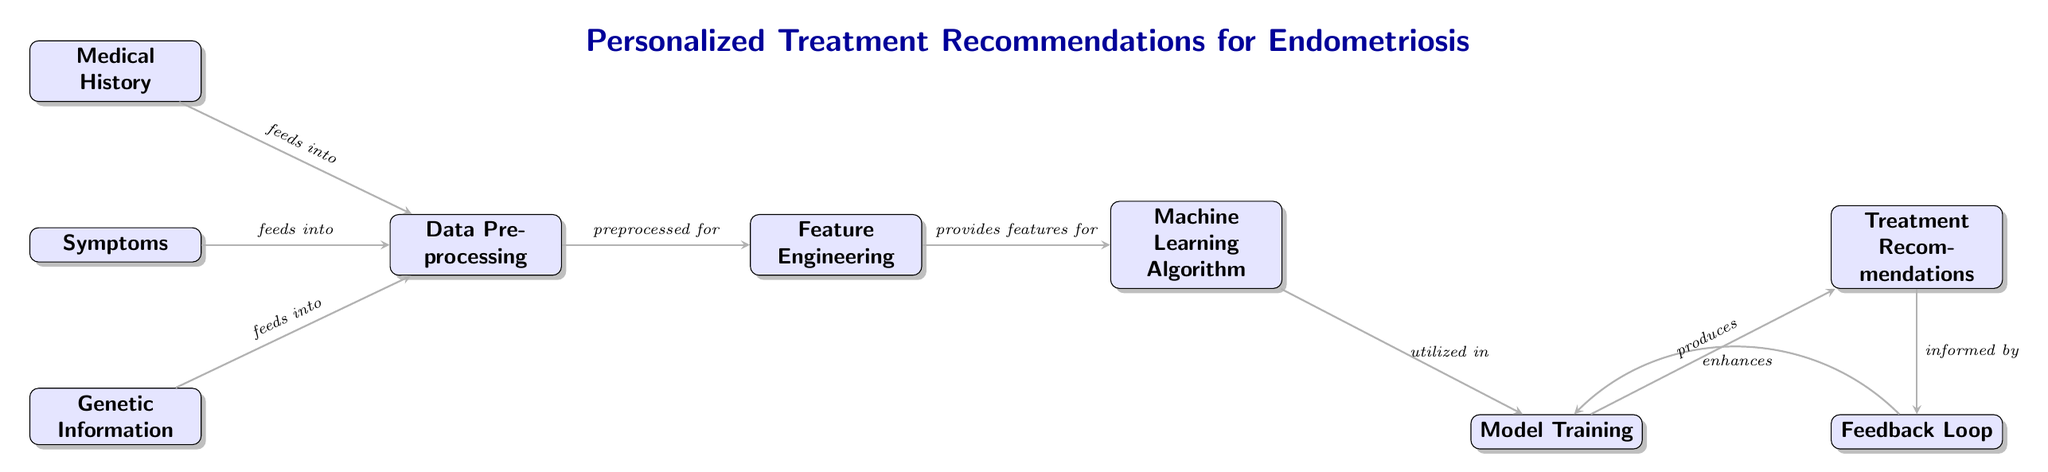What are the three types of input data to the model? The diagram shows three nodes at the beginning: "Medical History," "Symptoms," and "Genetic Information." These nodes represent the different types of input data that feed into the model.
Answer: Medical History, Symptoms, Genetic Information What process is applied after data preprocessing? The diagram illustrates an arrow leading from "Data Preprocessing" to "Feature Engineering." This indicates that "Feature Engineering" is the next step following data preprocessing.
Answer: Feature Engineering How many main nodes are in the diagram? By counting the distinct nodes present in the diagram, there are eight nodes in total: Medical History, Symptoms, Genetic Information, Data Preprocessing, Feature Engineering, Machine Learning Algorithm, Model Training, and Treatment Recommendations.
Answer: Eight What does the feedback loop do in the diagram? The feedback loop connects back to "Model Training" to enhance it. This indicates that the feedback obtained from "Treatment Recommendations" is used to improve the model's performance and recommendations.
Answer: Enhances model training Which node produces the treatment recommendations? The arrow connects "Model Training" to "Treatment Recommendations," indicating that "Treatment Recommendations" is generated from the training model.
Answer: Treatment Recommendations What type of algorithm is utilized in the process? The diagram specifies that there is a node labeled "Machine Learning Algorithm," indicating that a machine learning algorithm is used in the process of generating treatment recommendations.
Answer: Machine Learning Algorithm What indicates the relationship between the symptoms and data preprocessing? The arrow connecting "Symptoms" to "Data Preprocessing" demonstrates that symptoms are used as an input that feeds into the data preprocessing stage.
Answer: Feeds into What is the role of feature engineering according to the diagram? The arrow between "Feature Engineering" and "Machine Learning Algorithm" conveys that "Feature Engineering" provides important features to the machine learning algorithm that enhances its predictive capabilities.
Answer: Provides features for 